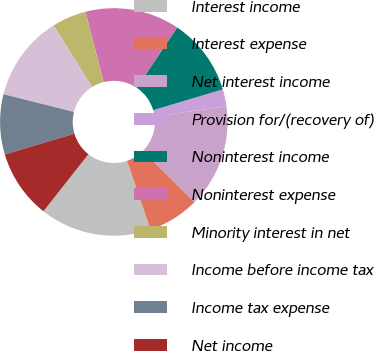<chart> <loc_0><loc_0><loc_500><loc_500><pie_chart><fcel>Interest income<fcel>Interest expense<fcel>Net interest income<fcel>Provision for/(recovery of)<fcel>Noninterest income<fcel>Noninterest expense<fcel>Minority interest in net<fcel>Income before income tax<fcel>Income tax expense<fcel>Net income<nl><fcel>15.85%<fcel>7.32%<fcel>14.63%<fcel>2.44%<fcel>10.98%<fcel>13.41%<fcel>4.88%<fcel>12.2%<fcel>8.54%<fcel>9.76%<nl></chart> 